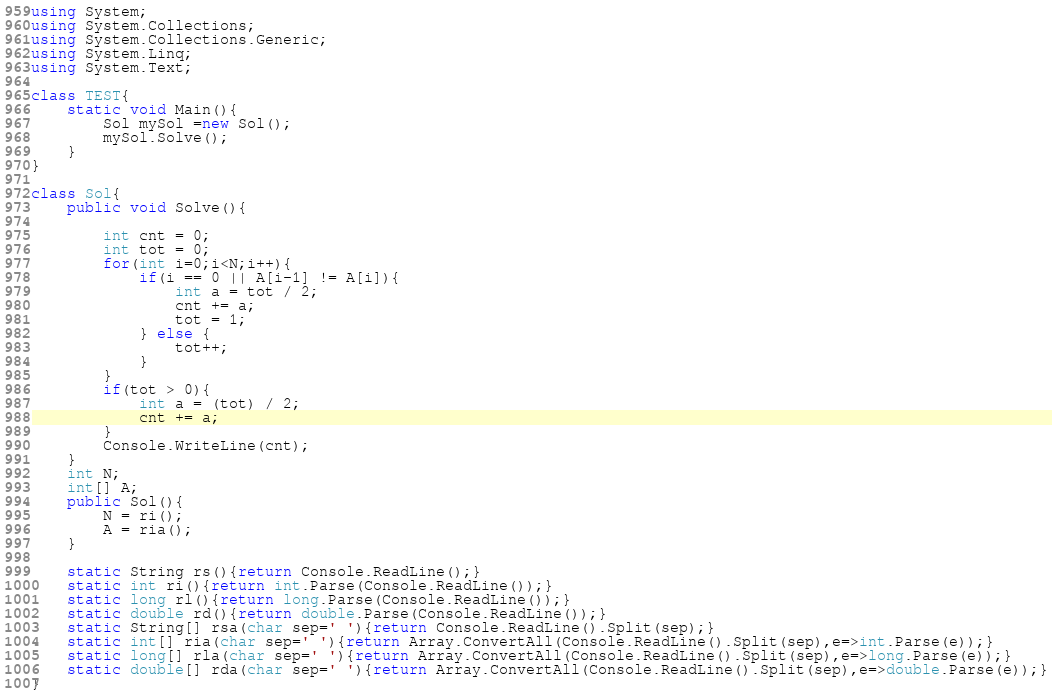Convert code to text. <code><loc_0><loc_0><loc_500><loc_500><_C#_>using System;
using System.Collections;
using System.Collections.Generic;
using System.Linq;
using System.Text;

class TEST{
	static void Main(){
		Sol mySol =new Sol();
		mySol.Solve();
	}
}

class Sol{
	public void Solve(){
		
		int cnt = 0;
		int tot = 0;
		for(int i=0;i<N;i++){
			if(i == 0 || A[i-1] != A[i]){
				int a = tot / 2;
				cnt += a;
				tot = 1;
			} else {
				tot++;
			}
		}
		if(tot > 0){
			int a = (tot) / 2;
			cnt += a;
		}
		Console.WriteLine(cnt);
	}
	int N;
	int[] A;
	public Sol(){
		N = ri();
		A = ria();
	}

	static String rs(){return Console.ReadLine();}
	static int ri(){return int.Parse(Console.ReadLine());}
	static long rl(){return long.Parse(Console.ReadLine());}
	static double rd(){return double.Parse(Console.ReadLine());}
	static String[] rsa(char sep=' '){return Console.ReadLine().Split(sep);}
	static int[] ria(char sep=' '){return Array.ConvertAll(Console.ReadLine().Split(sep),e=>int.Parse(e));}
	static long[] rla(char sep=' '){return Array.ConvertAll(Console.ReadLine().Split(sep),e=>long.Parse(e));}
	static double[] rda(char sep=' '){return Array.ConvertAll(Console.ReadLine().Split(sep),e=>double.Parse(e));}
}
</code> 